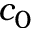<formula> <loc_0><loc_0><loc_500><loc_500>c _ { 0 }</formula> 